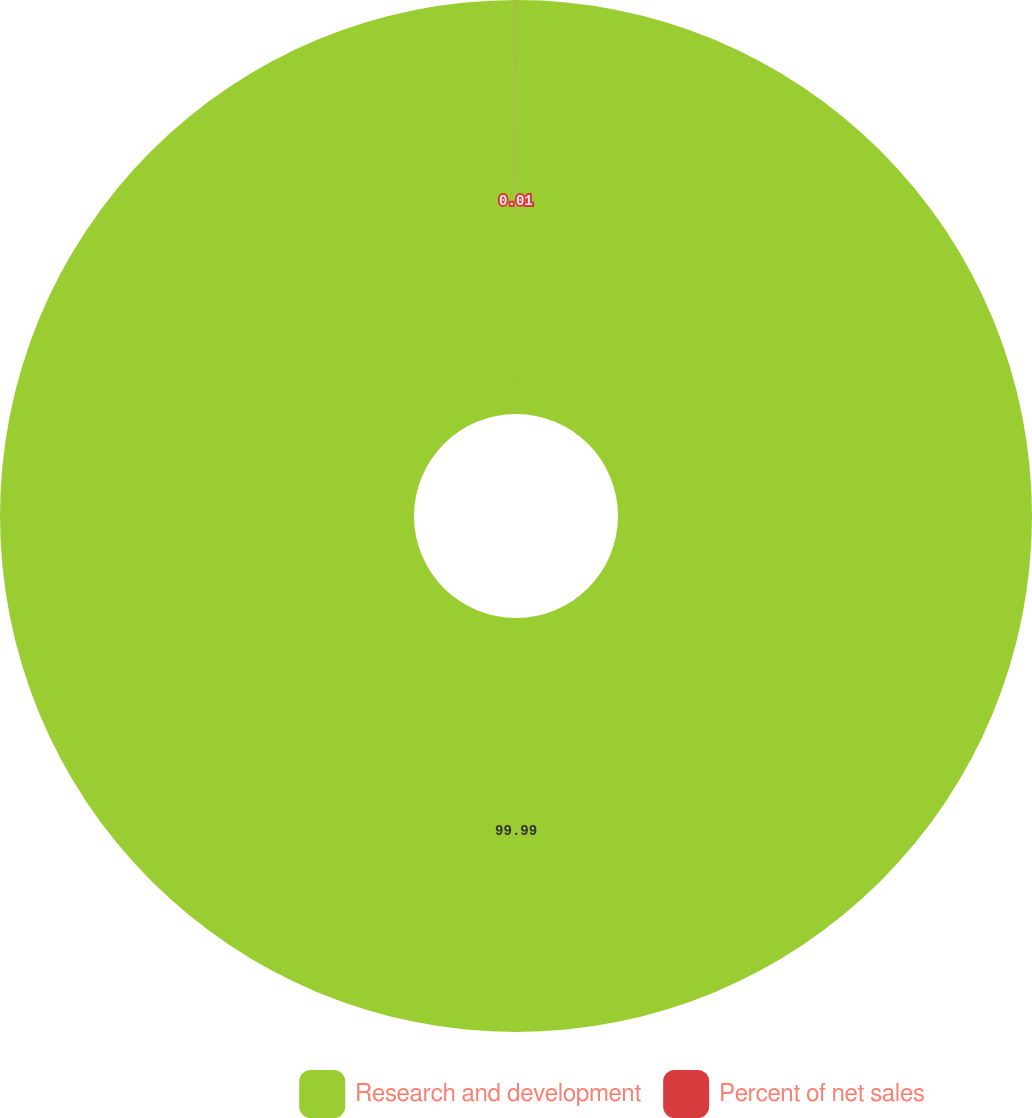<chart> <loc_0><loc_0><loc_500><loc_500><pie_chart><fcel>Research and development<fcel>Percent of net sales<nl><fcel>99.99%<fcel>0.01%<nl></chart> 